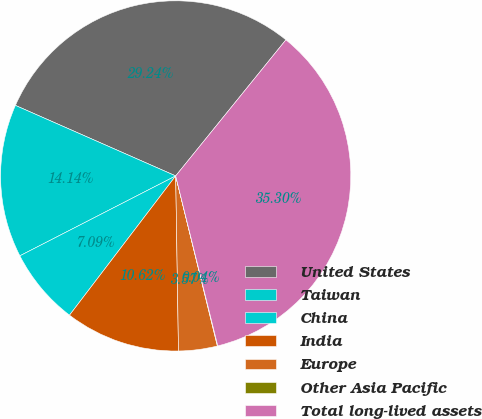<chart> <loc_0><loc_0><loc_500><loc_500><pie_chart><fcel>United States<fcel>Taiwan<fcel>China<fcel>India<fcel>Europe<fcel>Other Asia Pacific<fcel>Total long-lived assets<nl><fcel>29.24%<fcel>14.14%<fcel>7.09%<fcel>10.62%<fcel>3.57%<fcel>0.04%<fcel>35.3%<nl></chart> 